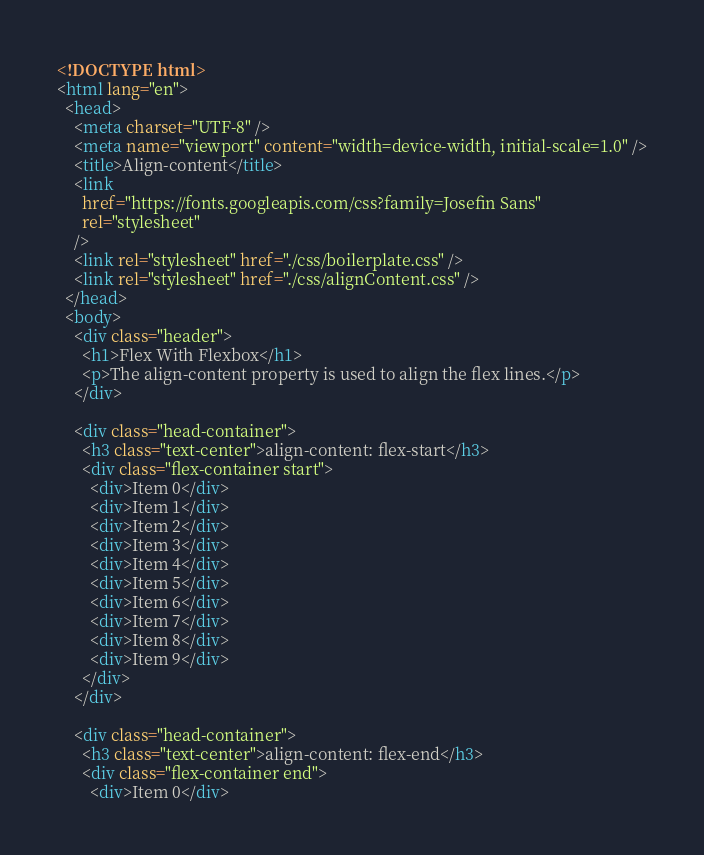<code> <loc_0><loc_0><loc_500><loc_500><_HTML_><!DOCTYPE html>
<html lang="en">
  <head>
    <meta charset="UTF-8" />
    <meta name="viewport" content="width=device-width, initial-scale=1.0" />
    <title>Align-content</title>
    <link
      href="https://fonts.googleapis.com/css?family=Josefin Sans"
      rel="stylesheet"
    />
    <link rel="stylesheet" href="./css/boilerplate.css" />
    <link rel="stylesheet" href="./css/alignContent.css" />
  </head>
  <body>
    <div class="header">
      <h1>Flex With Flexbox</h1>
      <p>The align-content property is used to align the flex lines.</p>
    </div>

    <div class="head-container">
      <h3 class="text-center">align-content: flex-start</h3>
      <div class="flex-container start">
        <div>Item 0</div>
        <div>Item 1</div>
        <div>Item 2</div>
        <div>Item 3</div>
        <div>Item 4</div>
        <div>Item 5</div>
        <div>Item 6</div>
        <div>Item 7</div>
        <div>Item 8</div>
        <div>Item 9</div>
      </div>
    </div>

    <div class="head-container">
      <h3 class="text-center">align-content: flex-end</h3>
      <div class="flex-container end">
        <div>Item 0</div></code> 